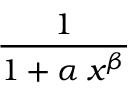<formula> <loc_0><loc_0><loc_500><loc_500>\frac { 1 } { 1 + \alpha \, x ^ { \beta } }</formula> 